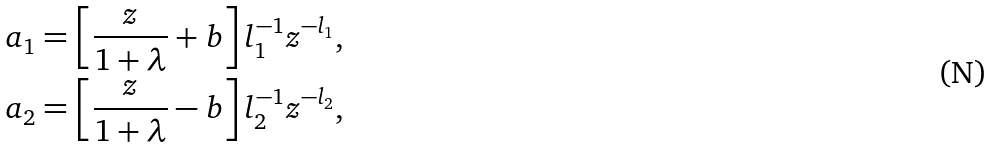Convert formula to latex. <formula><loc_0><loc_0><loc_500><loc_500>a _ { 1 } = \left [ \frac { z } { 1 + \lambda } + b \right ] l _ { 1 } ^ { - 1 } z ^ { - l _ { 1 } } , \\ a _ { 2 } = \left [ \frac { z } { 1 + \lambda } - b \right ] l _ { 2 } ^ { - 1 } z ^ { - l _ { 2 } } ,</formula> 